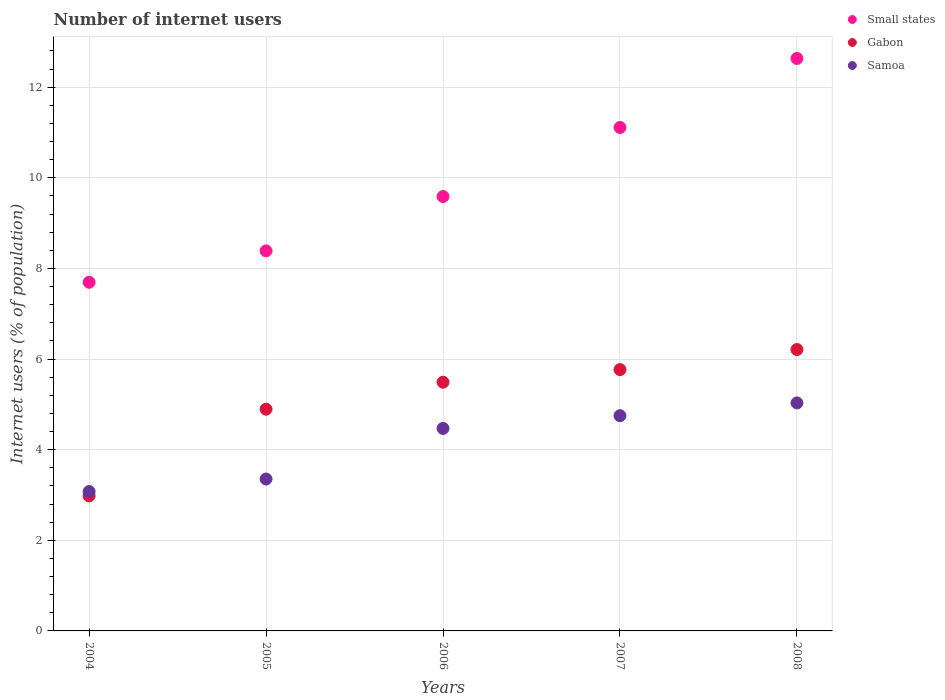What is the number of internet users in Samoa in 2007?
Ensure brevity in your answer.  4.75. Across all years, what is the maximum number of internet users in Small states?
Your answer should be compact. 12.63. Across all years, what is the minimum number of internet users in Samoa?
Ensure brevity in your answer.  3.08. In which year was the number of internet users in Gabon maximum?
Make the answer very short. 2008. In which year was the number of internet users in Small states minimum?
Provide a succinct answer. 2004. What is the total number of internet users in Small states in the graph?
Provide a short and direct response. 49.41. What is the difference between the number of internet users in Small states in 2006 and that in 2008?
Make the answer very short. -3.05. What is the difference between the number of internet users in Small states in 2004 and the number of internet users in Samoa in 2007?
Your answer should be compact. 2.94. What is the average number of internet users in Gabon per year?
Your answer should be very brief. 5.07. In the year 2005, what is the difference between the number of internet users in Samoa and number of internet users in Small states?
Your answer should be compact. -5.03. What is the ratio of the number of internet users in Gabon in 2004 to that in 2008?
Ensure brevity in your answer.  0.48. Is the number of internet users in Samoa in 2006 less than that in 2008?
Offer a terse response. Yes. What is the difference between the highest and the second highest number of internet users in Gabon?
Keep it short and to the point. 0.44. What is the difference between the highest and the lowest number of internet users in Samoa?
Make the answer very short. 1.96. Is it the case that in every year, the sum of the number of internet users in Samoa and number of internet users in Small states  is greater than the number of internet users in Gabon?
Your answer should be compact. Yes. Does the number of internet users in Small states monotonically increase over the years?
Offer a terse response. Yes. Is the number of internet users in Gabon strictly greater than the number of internet users in Samoa over the years?
Give a very brief answer. No. How many dotlines are there?
Your response must be concise. 3. What is the difference between two consecutive major ticks on the Y-axis?
Offer a terse response. 2. Are the values on the major ticks of Y-axis written in scientific E-notation?
Ensure brevity in your answer.  No. Where does the legend appear in the graph?
Offer a terse response. Top right. What is the title of the graph?
Ensure brevity in your answer.  Number of internet users. What is the label or title of the X-axis?
Give a very brief answer. Years. What is the label or title of the Y-axis?
Your answer should be very brief. Internet users (% of population). What is the Internet users (% of population) in Small states in 2004?
Ensure brevity in your answer.  7.69. What is the Internet users (% of population) of Gabon in 2004?
Your answer should be very brief. 2.98. What is the Internet users (% of population) of Samoa in 2004?
Your answer should be compact. 3.08. What is the Internet users (% of population) in Small states in 2005?
Your answer should be very brief. 8.39. What is the Internet users (% of population) of Gabon in 2005?
Ensure brevity in your answer.  4.89. What is the Internet users (% of population) of Samoa in 2005?
Offer a terse response. 3.35. What is the Internet users (% of population) of Small states in 2006?
Ensure brevity in your answer.  9.59. What is the Internet users (% of population) in Gabon in 2006?
Offer a very short reply. 5.49. What is the Internet users (% of population) in Samoa in 2006?
Your answer should be compact. 4.47. What is the Internet users (% of population) in Small states in 2007?
Keep it short and to the point. 11.11. What is the Internet users (% of population) in Gabon in 2007?
Offer a very short reply. 5.77. What is the Internet users (% of population) of Samoa in 2007?
Provide a short and direct response. 4.75. What is the Internet users (% of population) of Small states in 2008?
Provide a short and direct response. 12.63. What is the Internet users (% of population) in Gabon in 2008?
Offer a very short reply. 6.21. What is the Internet users (% of population) in Samoa in 2008?
Your response must be concise. 5.03. Across all years, what is the maximum Internet users (% of population) of Small states?
Provide a short and direct response. 12.63. Across all years, what is the maximum Internet users (% of population) in Gabon?
Offer a very short reply. 6.21. Across all years, what is the maximum Internet users (% of population) of Samoa?
Your answer should be very brief. 5.03. Across all years, what is the minimum Internet users (% of population) in Small states?
Ensure brevity in your answer.  7.69. Across all years, what is the minimum Internet users (% of population) in Gabon?
Your answer should be very brief. 2.98. Across all years, what is the minimum Internet users (% of population) of Samoa?
Your answer should be compact. 3.08. What is the total Internet users (% of population) of Small states in the graph?
Offer a very short reply. 49.41. What is the total Internet users (% of population) in Gabon in the graph?
Give a very brief answer. 25.34. What is the total Internet users (% of population) of Samoa in the graph?
Make the answer very short. 20.68. What is the difference between the Internet users (% of population) of Small states in 2004 and that in 2005?
Your response must be concise. -0.69. What is the difference between the Internet users (% of population) of Gabon in 2004 and that in 2005?
Your answer should be compact. -1.91. What is the difference between the Internet users (% of population) in Samoa in 2004 and that in 2005?
Ensure brevity in your answer.  -0.28. What is the difference between the Internet users (% of population) of Small states in 2004 and that in 2006?
Ensure brevity in your answer.  -1.89. What is the difference between the Internet users (% of population) in Gabon in 2004 and that in 2006?
Provide a short and direct response. -2.51. What is the difference between the Internet users (% of population) of Samoa in 2004 and that in 2006?
Keep it short and to the point. -1.39. What is the difference between the Internet users (% of population) of Small states in 2004 and that in 2007?
Provide a short and direct response. -3.42. What is the difference between the Internet users (% of population) of Gabon in 2004 and that in 2007?
Your answer should be compact. -2.79. What is the difference between the Internet users (% of population) in Samoa in 2004 and that in 2007?
Your answer should be very brief. -1.67. What is the difference between the Internet users (% of population) of Small states in 2004 and that in 2008?
Provide a short and direct response. -4.94. What is the difference between the Internet users (% of population) of Gabon in 2004 and that in 2008?
Ensure brevity in your answer.  -3.23. What is the difference between the Internet users (% of population) in Samoa in 2004 and that in 2008?
Make the answer very short. -1.96. What is the difference between the Internet users (% of population) in Small states in 2005 and that in 2006?
Keep it short and to the point. -1.2. What is the difference between the Internet users (% of population) of Gabon in 2005 and that in 2006?
Your response must be concise. -0.6. What is the difference between the Internet users (% of population) in Samoa in 2005 and that in 2006?
Make the answer very short. -1.12. What is the difference between the Internet users (% of population) of Small states in 2005 and that in 2007?
Make the answer very short. -2.72. What is the difference between the Internet users (% of population) of Gabon in 2005 and that in 2007?
Provide a succinct answer. -0.87. What is the difference between the Internet users (% of population) of Samoa in 2005 and that in 2007?
Make the answer very short. -1.4. What is the difference between the Internet users (% of population) in Small states in 2005 and that in 2008?
Keep it short and to the point. -4.25. What is the difference between the Internet users (% of population) of Gabon in 2005 and that in 2008?
Offer a very short reply. -1.32. What is the difference between the Internet users (% of population) of Samoa in 2005 and that in 2008?
Ensure brevity in your answer.  -1.68. What is the difference between the Internet users (% of population) of Small states in 2006 and that in 2007?
Offer a very short reply. -1.52. What is the difference between the Internet users (% of population) in Gabon in 2006 and that in 2007?
Your response must be concise. -0.28. What is the difference between the Internet users (% of population) of Samoa in 2006 and that in 2007?
Provide a succinct answer. -0.28. What is the difference between the Internet users (% of population) in Small states in 2006 and that in 2008?
Ensure brevity in your answer.  -3.05. What is the difference between the Internet users (% of population) in Gabon in 2006 and that in 2008?
Your response must be concise. -0.72. What is the difference between the Internet users (% of population) of Samoa in 2006 and that in 2008?
Your answer should be very brief. -0.56. What is the difference between the Internet users (% of population) in Small states in 2007 and that in 2008?
Provide a succinct answer. -1.52. What is the difference between the Internet users (% of population) of Gabon in 2007 and that in 2008?
Your answer should be compact. -0.44. What is the difference between the Internet users (% of population) in Samoa in 2007 and that in 2008?
Give a very brief answer. -0.28. What is the difference between the Internet users (% of population) in Small states in 2004 and the Internet users (% of population) in Gabon in 2005?
Your answer should be compact. 2.8. What is the difference between the Internet users (% of population) of Small states in 2004 and the Internet users (% of population) of Samoa in 2005?
Make the answer very short. 4.34. What is the difference between the Internet users (% of population) of Gabon in 2004 and the Internet users (% of population) of Samoa in 2005?
Your answer should be compact. -0.37. What is the difference between the Internet users (% of population) in Small states in 2004 and the Internet users (% of population) in Gabon in 2006?
Your answer should be compact. 2.21. What is the difference between the Internet users (% of population) of Small states in 2004 and the Internet users (% of population) of Samoa in 2006?
Offer a very short reply. 3.23. What is the difference between the Internet users (% of population) in Gabon in 2004 and the Internet users (% of population) in Samoa in 2006?
Your response must be concise. -1.49. What is the difference between the Internet users (% of population) of Small states in 2004 and the Internet users (% of population) of Gabon in 2007?
Your response must be concise. 1.93. What is the difference between the Internet users (% of population) in Small states in 2004 and the Internet users (% of population) in Samoa in 2007?
Make the answer very short. 2.94. What is the difference between the Internet users (% of population) in Gabon in 2004 and the Internet users (% of population) in Samoa in 2007?
Provide a succinct answer. -1.77. What is the difference between the Internet users (% of population) of Small states in 2004 and the Internet users (% of population) of Gabon in 2008?
Give a very brief answer. 1.48. What is the difference between the Internet users (% of population) of Small states in 2004 and the Internet users (% of population) of Samoa in 2008?
Make the answer very short. 2.66. What is the difference between the Internet users (% of population) of Gabon in 2004 and the Internet users (% of population) of Samoa in 2008?
Your answer should be very brief. -2.05. What is the difference between the Internet users (% of population) of Small states in 2005 and the Internet users (% of population) of Gabon in 2006?
Your answer should be very brief. 2.9. What is the difference between the Internet users (% of population) in Small states in 2005 and the Internet users (% of population) in Samoa in 2006?
Provide a short and direct response. 3.92. What is the difference between the Internet users (% of population) of Gabon in 2005 and the Internet users (% of population) of Samoa in 2006?
Provide a short and direct response. 0.42. What is the difference between the Internet users (% of population) of Small states in 2005 and the Internet users (% of population) of Gabon in 2007?
Offer a terse response. 2.62. What is the difference between the Internet users (% of population) in Small states in 2005 and the Internet users (% of population) in Samoa in 2007?
Make the answer very short. 3.64. What is the difference between the Internet users (% of population) in Gabon in 2005 and the Internet users (% of population) in Samoa in 2007?
Provide a succinct answer. 0.14. What is the difference between the Internet users (% of population) of Small states in 2005 and the Internet users (% of population) of Gabon in 2008?
Make the answer very short. 2.18. What is the difference between the Internet users (% of population) of Small states in 2005 and the Internet users (% of population) of Samoa in 2008?
Offer a very short reply. 3.36. What is the difference between the Internet users (% of population) in Gabon in 2005 and the Internet users (% of population) in Samoa in 2008?
Offer a terse response. -0.14. What is the difference between the Internet users (% of population) of Small states in 2006 and the Internet users (% of population) of Gabon in 2007?
Keep it short and to the point. 3.82. What is the difference between the Internet users (% of population) of Small states in 2006 and the Internet users (% of population) of Samoa in 2007?
Offer a terse response. 4.84. What is the difference between the Internet users (% of population) of Gabon in 2006 and the Internet users (% of population) of Samoa in 2007?
Give a very brief answer. 0.74. What is the difference between the Internet users (% of population) in Small states in 2006 and the Internet users (% of population) in Gabon in 2008?
Provide a succinct answer. 3.38. What is the difference between the Internet users (% of population) in Small states in 2006 and the Internet users (% of population) in Samoa in 2008?
Offer a very short reply. 4.56. What is the difference between the Internet users (% of population) of Gabon in 2006 and the Internet users (% of population) of Samoa in 2008?
Offer a terse response. 0.46. What is the difference between the Internet users (% of population) of Small states in 2007 and the Internet users (% of population) of Gabon in 2008?
Your answer should be compact. 4.9. What is the difference between the Internet users (% of population) of Small states in 2007 and the Internet users (% of population) of Samoa in 2008?
Ensure brevity in your answer.  6.08. What is the difference between the Internet users (% of population) in Gabon in 2007 and the Internet users (% of population) in Samoa in 2008?
Keep it short and to the point. 0.74. What is the average Internet users (% of population) in Small states per year?
Make the answer very short. 9.88. What is the average Internet users (% of population) of Gabon per year?
Offer a terse response. 5.07. What is the average Internet users (% of population) in Samoa per year?
Offer a terse response. 4.14. In the year 2004, what is the difference between the Internet users (% of population) of Small states and Internet users (% of population) of Gabon?
Provide a short and direct response. 4.72. In the year 2004, what is the difference between the Internet users (% of population) of Small states and Internet users (% of population) of Samoa?
Provide a succinct answer. 4.62. In the year 2004, what is the difference between the Internet users (% of population) of Gabon and Internet users (% of population) of Samoa?
Offer a very short reply. -0.1. In the year 2005, what is the difference between the Internet users (% of population) of Small states and Internet users (% of population) of Gabon?
Provide a short and direct response. 3.49. In the year 2005, what is the difference between the Internet users (% of population) of Small states and Internet users (% of population) of Samoa?
Provide a succinct answer. 5.04. In the year 2005, what is the difference between the Internet users (% of population) of Gabon and Internet users (% of population) of Samoa?
Your answer should be very brief. 1.54. In the year 2006, what is the difference between the Internet users (% of population) in Small states and Internet users (% of population) in Gabon?
Provide a short and direct response. 4.1. In the year 2006, what is the difference between the Internet users (% of population) of Small states and Internet users (% of population) of Samoa?
Ensure brevity in your answer.  5.12. In the year 2006, what is the difference between the Internet users (% of population) of Gabon and Internet users (% of population) of Samoa?
Offer a very short reply. 1.02. In the year 2007, what is the difference between the Internet users (% of population) of Small states and Internet users (% of population) of Gabon?
Your answer should be very brief. 5.34. In the year 2007, what is the difference between the Internet users (% of population) in Small states and Internet users (% of population) in Samoa?
Make the answer very short. 6.36. In the year 2007, what is the difference between the Internet users (% of population) in Gabon and Internet users (% of population) in Samoa?
Offer a terse response. 1.02. In the year 2008, what is the difference between the Internet users (% of population) of Small states and Internet users (% of population) of Gabon?
Your answer should be very brief. 6.42. In the year 2008, what is the difference between the Internet users (% of population) of Small states and Internet users (% of population) of Samoa?
Provide a succinct answer. 7.6. In the year 2008, what is the difference between the Internet users (% of population) of Gabon and Internet users (% of population) of Samoa?
Provide a short and direct response. 1.18. What is the ratio of the Internet users (% of population) in Small states in 2004 to that in 2005?
Your answer should be very brief. 0.92. What is the ratio of the Internet users (% of population) in Gabon in 2004 to that in 2005?
Your response must be concise. 0.61. What is the ratio of the Internet users (% of population) in Samoa in 2004 to that in 2005?
Your answer should be very brief. 0.92. What is the ratio of the Internet users (% of population) of Small states in 2004 to that in 2006?
Provide a succinct answer. 0.8. What is the ratio of the Internet users (% of population) of Gabon in 2004 to that in 2006?
Ensure brevity in your answer.  0.54. What is the ratio of the Internet users (% of population) of Samoa in 2004 to that in 2006?
Make the answer very short. 0.69. What is the ratio of the Internet users (% of population) of Small states in 2004 to that in 2007?
Offer a very short reply. 0.69. What is the ratio of the Internet users (% of population) of Gabon in 2004 to that in 2007?
Offer a terse response. 0.52. What is the ratio of the Internet users (% of population) in Samoa in 2004 to that in 2007?
Provide a succinct answer. 0.65. What is the ratio of the Internet users (% of population) of Small states in 2004 to that in 2008?
Your response must be concise. 0.61. What is the ratio of the Internet users (% of population) of Gabon in 2004 to that in 2008?
Your answer should be compact. 0.48. What is the ratio of the Internet users (% of population) in Samoa in 2004 to that in 2008?
Your answer should be very brief. 0.61. What is the ratio of the Internet users (% of population) of Small states in 2005 to that in 2006?
Keep it short and to the point. 0.87. What is the ratio of the Internet users (% of population) in Gabon in 2005 to that in 2006?
Keep it short and to the point. 0.89. What is the ratio of the Internet users (% of population) in Samoa in 2005 to that in 2006?
Your response must be concise. 0.75. What is the ratio of the Internet users (% of population) in Small states in 2005 to that in 2007?
Make the answer very short. 0.75. What is the ratio of the Internet users (% of population) of Gabon in 2005 to that in 2007?
Keep it short and to the point. 0.85. What is the ratio of the Internet users (% of population) in Samoa in 2005 to that in 2007?
Offer a very short reply. 0.71. What is the ratio of the Internet users (% of population) in Small states in 2005 to that in 2008?
Offer a very short reply. 0.66. What is the ratio of the Internet users (% of population) of Gabon in 2005 to that in 2008?
Offer a terse response. 0.79. What is the ratio of the Internet users (% of population) in Samoa in 2005 to that in 2008?
Your response must be concise. 0.67. What is the ratio of the Internet users (% of population) in Small states in 2006 to that in 2007?
Provide a short and direct response. 0.86. What is the ratio of the Internet users (% of population) of Gabon in 2006 to that in 2007?
Keep it short and to the point. 0.95. What is the ratio of the Internet users (% of population) in Samoa in 2006 to that in 2007?
Offer a very short reply. 0.94. What is the ratio of the Internet users (% of population) in Small states in 2006 to that in 2008?
Ensure brevity in your answer.  0.76. What is the ratio of the Internet users (% of population) of Gabon in 2006 to that in 2008?
Provide a succinct answer. 0.88. What is the ratio of the Internet users (% of population) in Samoa in 2006 to that in 2008?
Keep it short and to the point. 0.89. What is the ratio of the Internet users (% of population) of Small states in 2007 to that in 2008?
Ensure brevity in your answer.  0.88. What is the ratio of the Internet users (% of population) of Gabon in 2007 to that in 2008?
Ensure brevity in your answer.  0.93. What is the ratio of the Internet users (% of population) in Samoa in 2007 to that in 2008?
Provide a short and direct response. 0.94. What is the difference between the highest and the second highest Internet users (% of population) of Small states?
Offer a terse response. 1.52. What is the difference between the highest and the second highest Internet users (% of population) of Gabon?
Offer a terse response. 0.44. What is the difference between the highest and the second highest Internet users (% of population) of Samoa?
Ensure brevity in your answer.  0.28. What is the difference between the highest and the lowest Internet users (% of population) in Small states?
Offer a very short reply. 4.94. What is the difference between the highest and the lowest Internet users (% of population) in Gabon?
Provide a succinct answer. 3.23. What is the difference between the highest and the lowest Internet users (% of population) in Samoa?
Give a very brief answer. 1.96. 